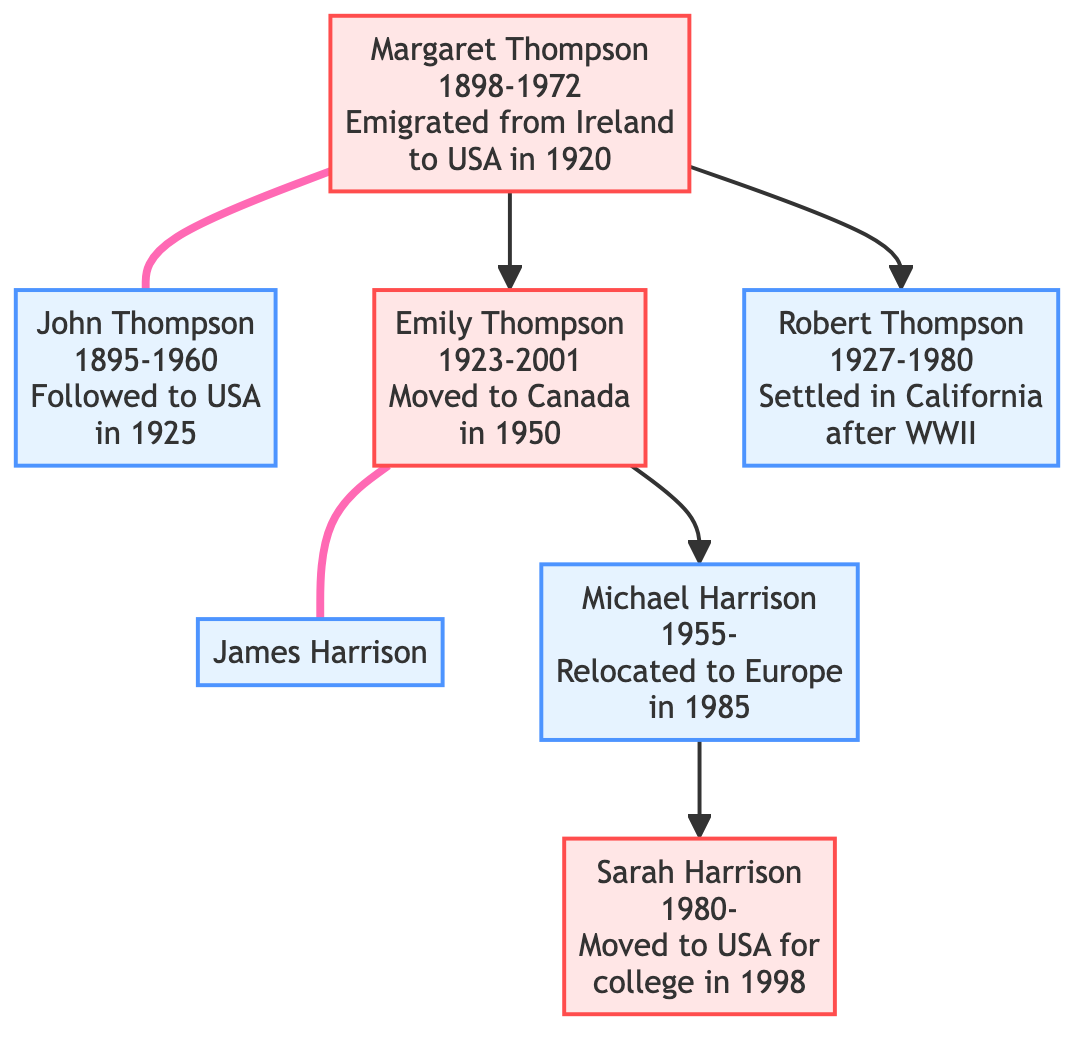What is the birth year of Margaret Thompson? The birth year of Margaret Thompson is listed directly in the diagram as 1898.
Answer: 1898 How many children did Margaret Thompson have? The diagram shows two connections where Margaret Thompson is a parent: one to Emily Thompson and one to Robert Thompson. Therefore, she had two children.
Answer: 2 Who did Emily Thompson marry? The diagram shows a direct connection between Emily Thompson and another node labeled James Harrison, indicating that he is her husband.
Answer: James Harrison What year did Margaret and John Thompson get married? The year of marriage between Margaret Thompson and John Thompson is specified in the diagram as 1921, providing a clear date of their union.
Answer: 1921 Which generation did Michael Harrison belong to? By examining the family structure, Michael Harrison is the son of Emily Thompson, who is the child of Margaret Thompson, placing him in the third generation.
Answer: Third generation How many migrations did Robert Thompson make? The diagram indicates that Robert Thompson settled in California after serving in the military, but does not indicate any other migratory movements, so he made one migration.
Answer: 1 Who is the grandparent of Sarah Harrison? The diagram shows that Michael Harrison is the parent of Sarah Harrison and that Michael's parent is Emily Thompson, making Emily Thompson Sarah’s grandparent.
Answer: Emily Thompson In what year did Sarah Harrison move to the United States for college? According to the diagram, Sarah Harrison moved back to the United States for college in 1998, which is explicitly mentioned next to her information.
Answer: 1998 Where did Michael Harrison relocate for business? The migration description in the diagram states that Michael Harrison relocated to Europe for business in 1985, clearly identifying the location of his move.
Answer: Europe 